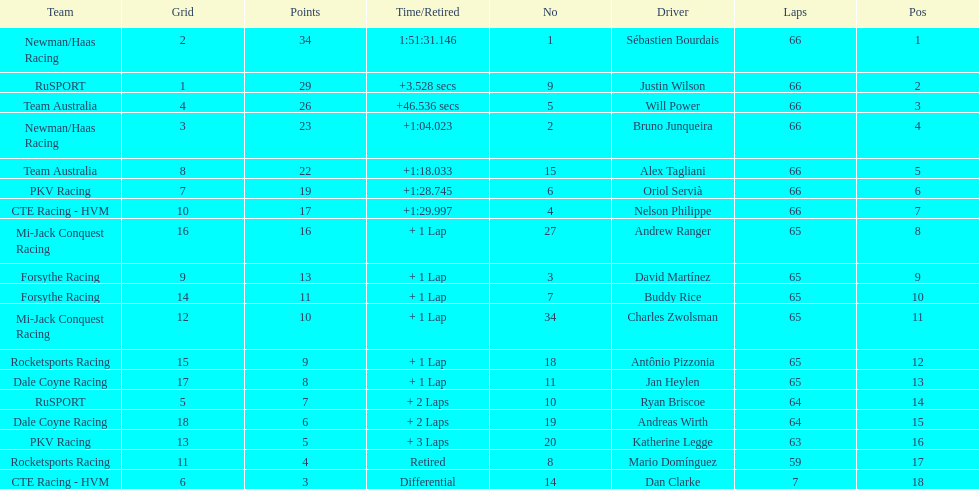Which country is represented by the most drivers? United Kingdom. 